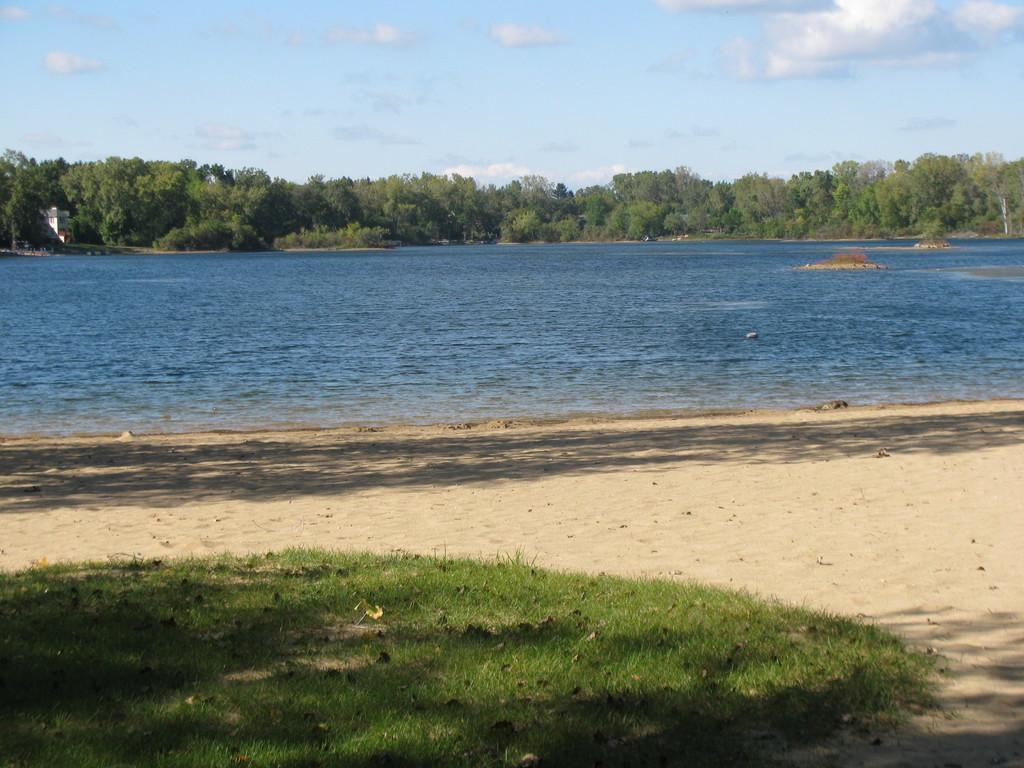Describe this image in one or two sentences. In this image, we can see sand and grass. In the background, we can see the water and cloudy sky. 